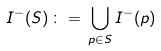Convert formula to latex. <formula><loc_0><loc_0><loc_500><loc_500>I ^ { - } ( S ) \, \colon = \, \bigcup _ { p \in S } I ^ { - } ( p )</formula> 